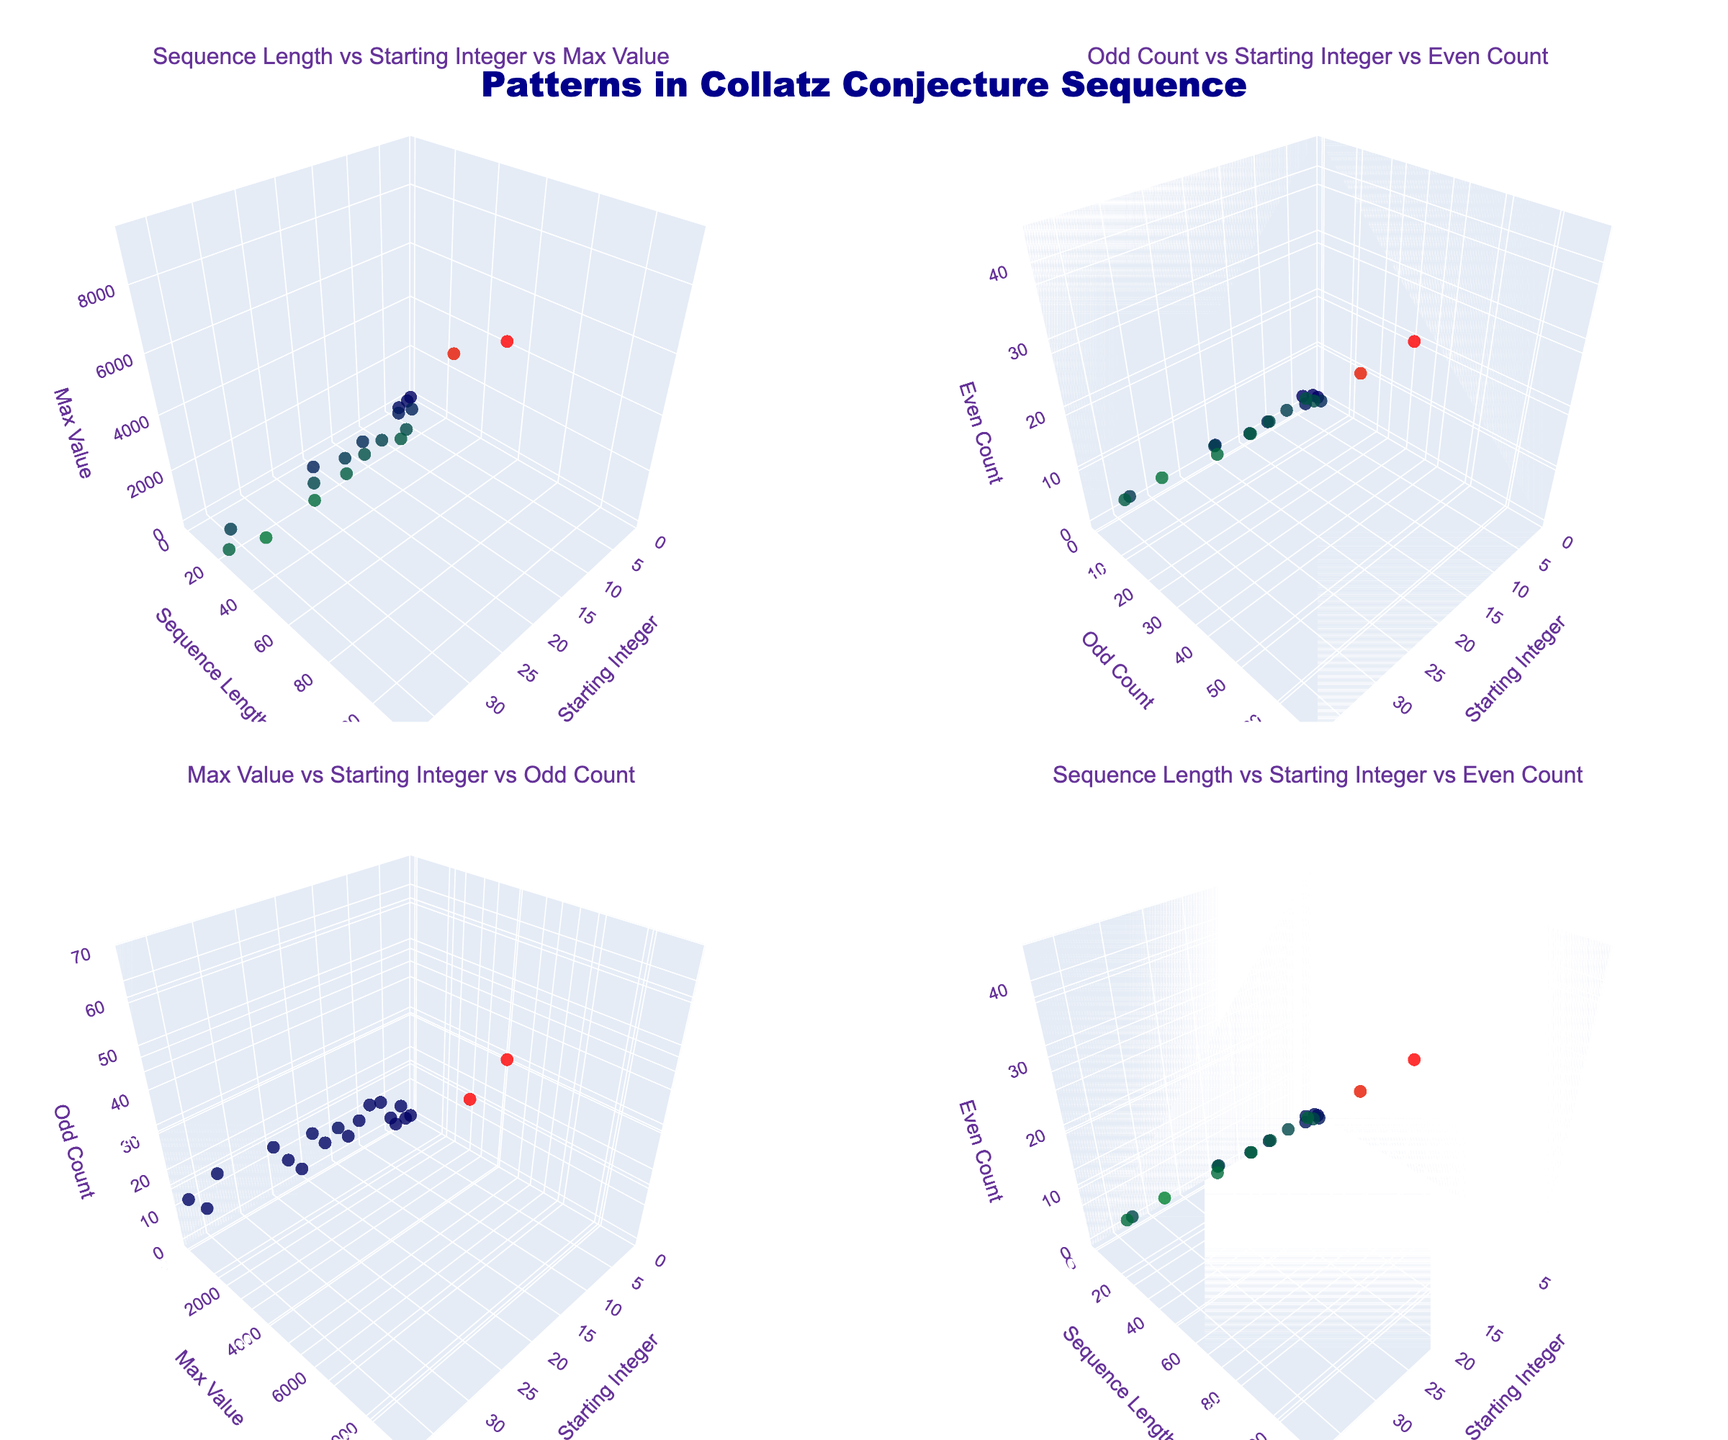What is the title of the figure? The title is typically placed at the top of the figure and is used to give a brief description of what the plots represent. In this case, it looks like the title is set in the code.
Answer: Patterns in Collatz Conjecture Sequence How many subplots are present in the figure? The figure is created using a grid of rows and columns with each cell being a subplot. The code shows that there are 2 rows and 2 columns making a total of 4 subplots.
Answer: 4 What are the axis titles for the first subplot? Axis titles provide information about what each axis represents. According to the code, for the first subplot, the x-axis is "Starting Integer", the y-axis is "Sequence Length", and the z-axis is "Max Value".
Answer: Starting Integer, Sequence Length, Max Value Which starting integer has the highest sequence length in the fourth subplot? The text shows sequence lengths for different starting integers against their even counts in the fourth subplot. By identifying the data point with the highest sequence length, we can find the corresponding starting integer.
Answer: 27 How do the sequence lengths generally trend with increasing starting integers in the first subplot? To answer this question, observe the distribution of data points in the first subplot. The appearance of the points will reveal the general trend such as whether sequence lengths tend to increase, decrease, or stay constant.
Answer: Trend upwards in variance Which subplot shows the relationship between odd count and even count, and what are the axes titles? By reading the subplot titles and the specified axes, you can locate the subplot that displays odd count versus even count and identify titles assigned to each axis in this subplot.
Answer: Second subplot; Starting Integer, Odd Count, Even Count What is the maximum value achieved by starting integer 3 in the first subplot? Locate the point where the starting integer is 3 in the first subplot and check the z-axis value (max value) for that specific point. This provides the information required.
Answer: 16 Compare the maximum values between starting integers 25 and 27 in the third subplot. Which starting integer has a higher max value? By examining the third subplot, locate the data points for starting integers 25 and 27. Compare their corresponding z-axis values (max values).
Answer: 27 What can be inferred about the relationship between sequence length and even count based on the fourth subplot? Observe the distribution of data points in the fourth subplot to understand whether there's an apparent relationship such as a direct proportion, inverse proportion, or no clear pattern between sequence length and even count.
Answer: Positive correlation Among the visible trends, which starting integer seems to have data points with a notable deviation in odd counts in the second subplot? Look at the second subplot where odd counts are plotted and identify the starting integer that has data points significantly deviating from the rest in terms of odd count.
Answer: 27 